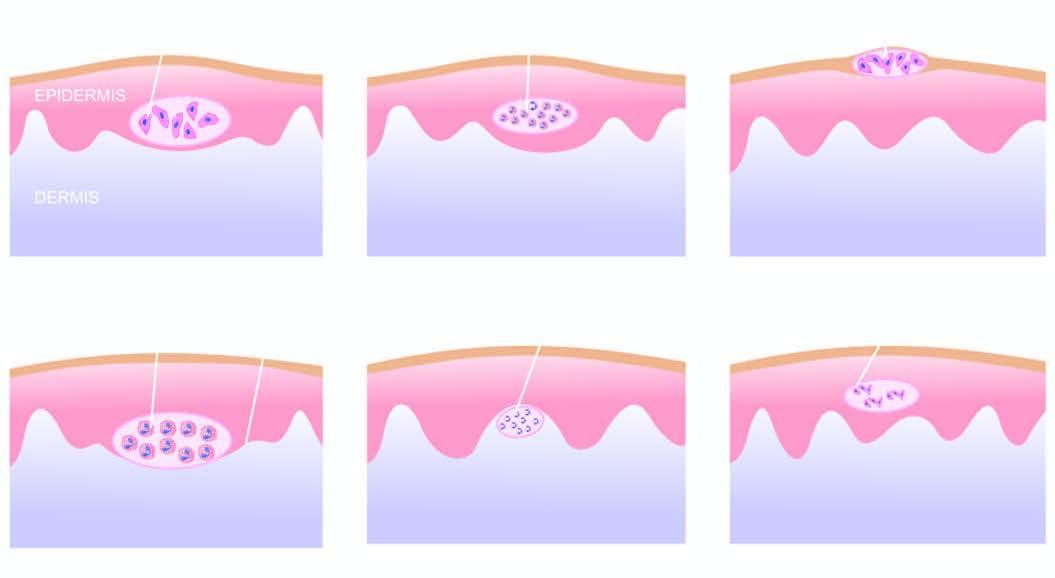what is a papillary microabscess composed of?
Answer the question using a single word or phrase. Neutrophils 